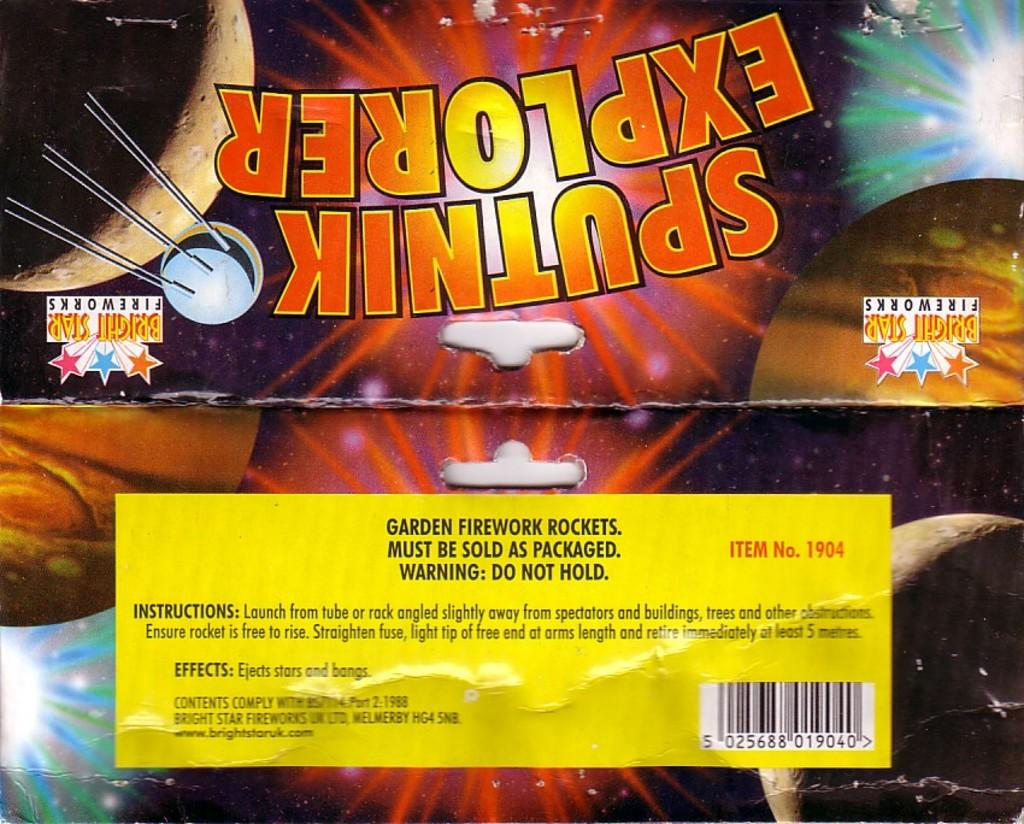<image>
Offer a succinct explanation of the picture presented. A package of fireworks has the brand name Bright Star Fireworks on it. 